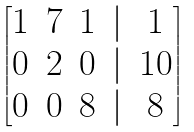<formula> <loc_0><loc_0><loc_500><loc_500>\begin{bmatrix} 1 & 7 & 1 & | & 1 \\ 0 & 2 & 0 & | & 1 0 \\ 0 & 0 & 8 & | & 8 \end{bmatrix}</formula> 